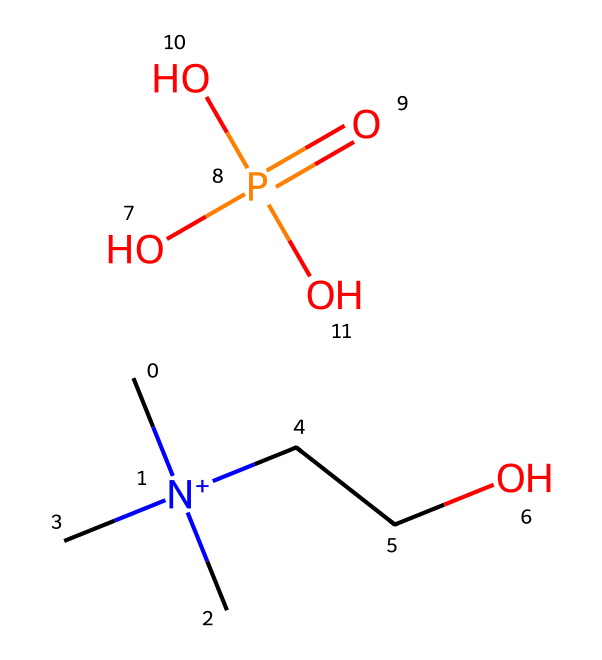What is the total number of hydrogen atoms in choline dihydrogen phosphate? To find the total number of hydrogen atoms, we can examine the SMILES representation. The structure includes two methyl groups from the choline (each contributing 3 hydrogen atoms), a propyl group that adds 2 hydrogen atoms, and three additional hydrogens from the dihydrogen phosphate part. Adding these gives a total of 11 hydrogen atoms.
Answer: 11 How many oxygen atoms are present in choline dihydrogen phosphate? By analyzing the SMILES, we can count the oxygen atoms. There are three oxygen atoms in the phosphate (P=O and two P-OH), leading to a total of three oxygen atoms overall.
Answer: 4 What type of chemical is choline dihydrogen phosphate considered? Choline dihydrogen phosphate is categorized as an ionic liquid due to its ionic nature at room temperature and its ability to dissolve salts and act as a solvent.
Answer: ionic liquid What is the charge of the nitrogen atom in the choline component? The nitrogen atom in choline is quaternary as it is attached to four groups, giving it a +1 positive charge. This indicates it is part of the cation in the ionic liquid.
Answer: +1 What functional groups can be identified in choline dihydrogen phosphate? The SMILES shows both a quaternary ammonium group (from choline) and a phosphate group (P(=O)(O)(O)) indicating the presence of these functional groups within the ionic liquid structure.
Answer: quaternary ammonium, phosphate What does the presence of the phosphate group suggest about its potential bioactivity? The phosphate group generally plays a significant role in biological systems, often associated with neuroprotective and signaling functions, enhancing the molecule's potential therapeutic effects.
Answer: bioactivity potential 